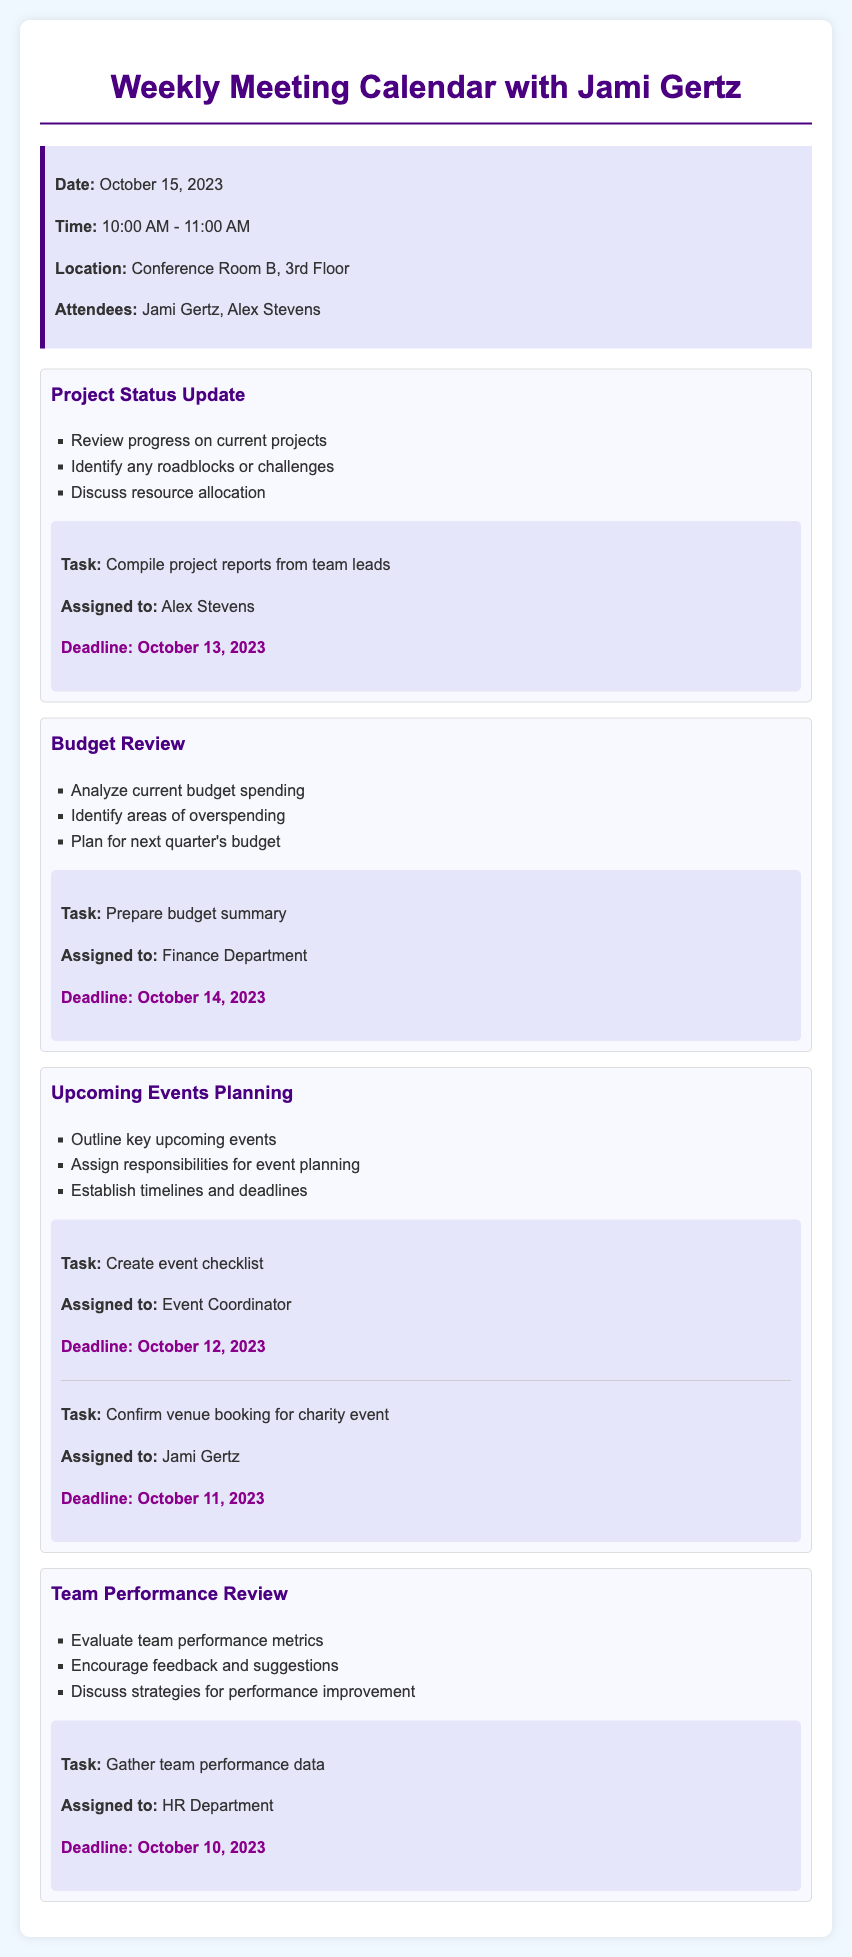What is the date of the meeting? The date of the meeting is specified in the document, which is October 15, 2023.
Answer: October 15, 2023 Who is assigned to compile project reports? The document lists the task and who is responsible for it, stating that Alex Stevens is assigned to compile project reports.
Answer: Alex Stevens What time does the meeting start? The meeting time is provided in the document, stating it starts at 10:00 AM.
Answer: 10:00 AM What is the deadline for confirming the venue booking? The document includes specific deadlines for tasks, indicating the deadline for confirming the venue booking is October 11, 2023.
Answer: October 11, 2023 How many agenda items were discussed? The document lists the agenda items and includes four distinct items presented during the meeting.
Answer: 4 Which department is preparing the budget summary? The document indicates that the Finance Department is responsible for preparing the budget summary.
Answer: Finance Department What is the topic of the first agenda item? The document clearly states that the first agenda item is "Project Status Update."
Answer: Project Status Update What is the location of the meeting? The meeting's location is provided in the document as Conference Room B, 3rd Floor.
Answer: Conference Room B, 3rd Floor What is the task assigned to the HR Department? The document details a task assigned to the HR Department to gather team performance data.
Answer: Gather team performance data 